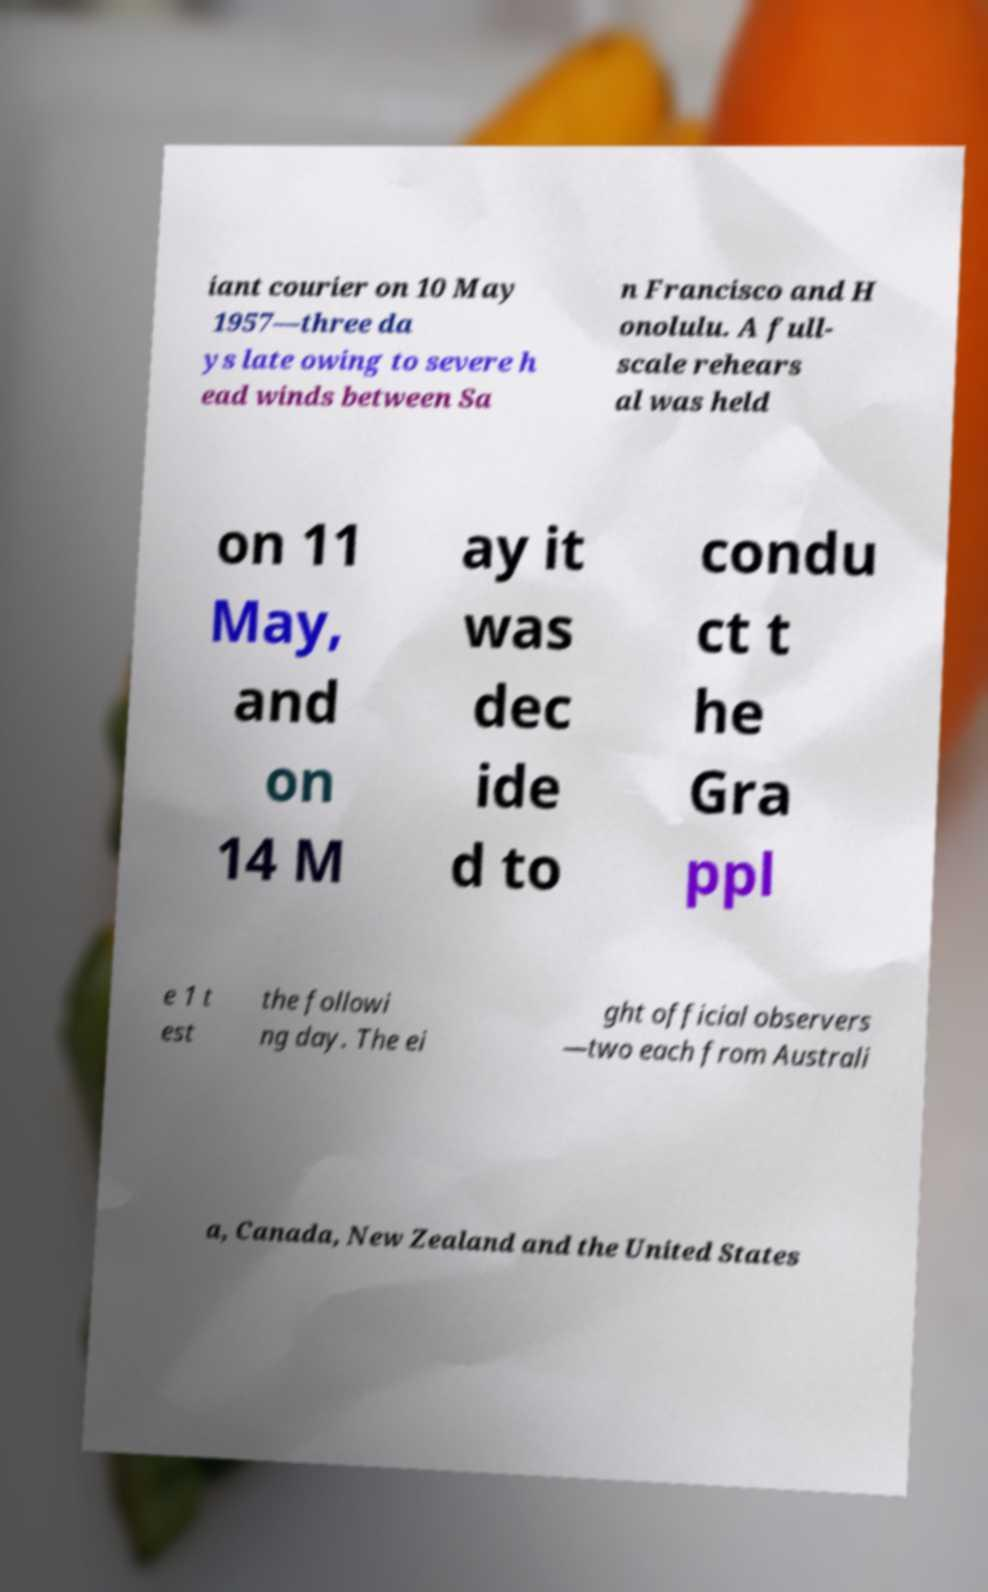Can you accurately transcribe the text from the provided image for me? iant courier on 10 May 1957—three da ys late owing to severe h ead winds between Sa n Francisco and H onolulu. A full- scale rehears al was held on 11 May, and on 14 M ay it was dec ide d to condu ct t he Gra ppl e 1 t est the followi ng day. The ei ght official observers —two each from Australi a, Canada, New Zealand and the United States 